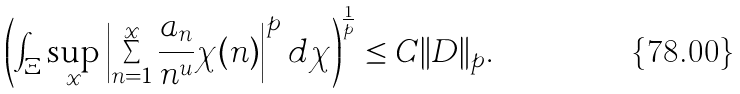Convert formula to latex. <formula><loc_0><loc_0><loc_500><loc_500>\left ( \int _ { \Xi } \sup _ { x } \left | \sum _ { n = 1 } ^ { x } \frac { a _ { n } } { n ^ { u } } \chi ( n ) \right | ^ { p } d \chi \right ) ^ { \frac { 1 } { p } } \leq C \| D \| _ { p } .</formula> 